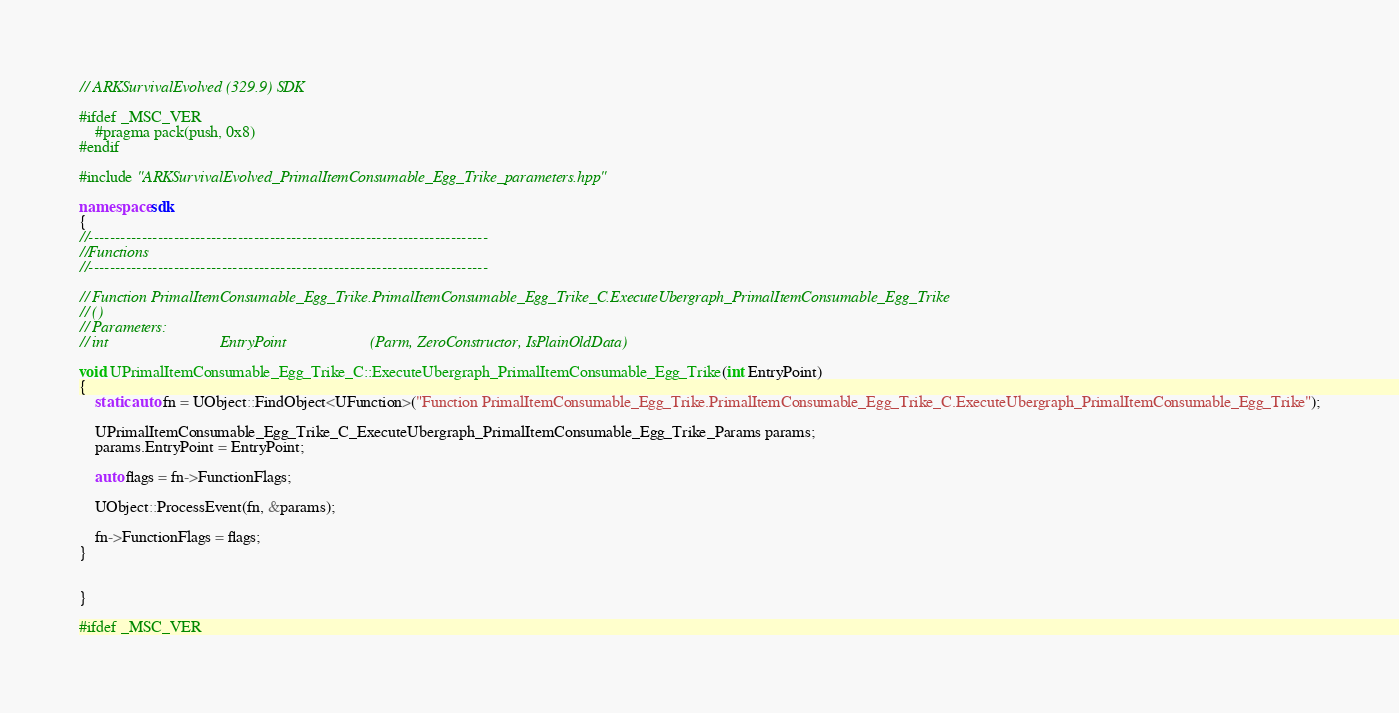<code> <loc_0><loc_0><loc_500><loc_500><_C++_>// ARKSurvivalEvolved (329.9) SDK

#ifdef _MSC_VER
	#pragma pack(push, 0x8)
#endif

#include "ARKSurvivalEvolved_PrimalItemConsumable_Egg_Trike_parameters.hpp"

namespace sdk
{
//---------------------------------------------------------------------------
//Functions
//---------------------------------------------------------------------------

// Function PrimalItemConsumable_Egg_Trike.PrimalItemConsumable_Egg_Trike_C.ExecuteUbergraph_PrimalItemConsumable_Egg_Trike
// ()
// Parameters:
// int                            EntryPoint                     (Parm, ZeroConstructor, IsPlainOldData)

void UPrimalItemConsumable_Egg_Trike_C::ExecuteUbergraph_PrimalItemConsumable_Egg_Trike(int EntryPoint)
{
	static auto fn = UObject::FindObject<UFunction>("Function PrimalItemConsumable_Egg_Trike.PrimalItemConsumable_Egg_Trike_C.ExecuteUbergraph_PrimalItemConsumable_Egg_Trike");

	UPrimalItemConsumable_Egg_Trike_C_ExecuteUbergraph_PrimalItemConsumable_Egg_Trike_Params params;
	params.EntryPoint = EntryPoint;

	auto flags = fn->FunctionFlags;

	UObject::ProcessEvent(fn, &params);

	fn->FunctionFlags = flags;
}


}

#ifdef _MSC_VER</code> 